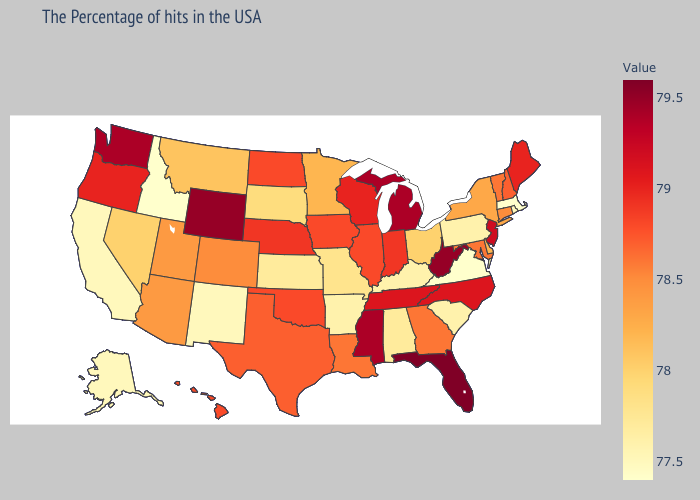Does Louisiana have the lowest value in the South?
Short answer required. No. Does Georgia have the lowest value in the USA?
Be succinct. No. Does California have the highest value in the West?
Short answer required. No. Among the states that border Nebraska , which have the highest value?
Concise answer only. Wyoming. Does New Jersey have the lowest value in the Northeast?
Quick response, please. No. Among the states that border Ohio , does Pennsylvania have the lowest value?
Be succinct. Yes. Which states hav the highest value in the Northeast?
Concise answer only. New Jersey. 